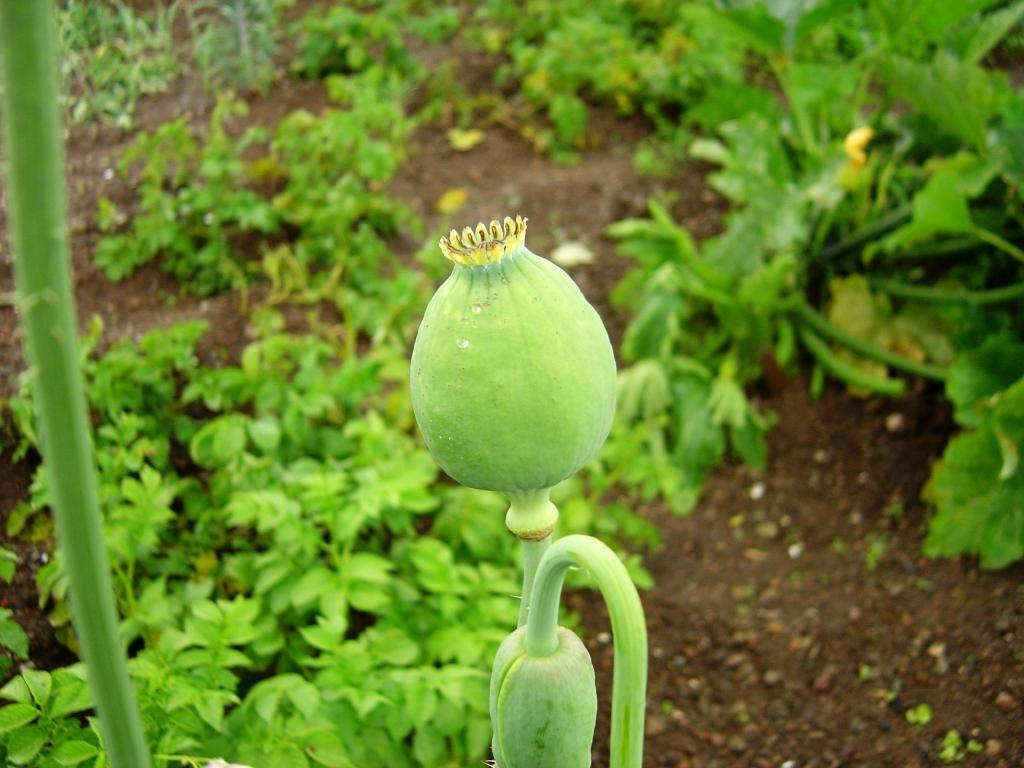Can you describe this image briefly? In the center of the image we can see one plant. On the plant, we can see one fruit type object, which is in green color. On the right side of the image, we can see one green stick. In the background we can see planets and a few other objects. 